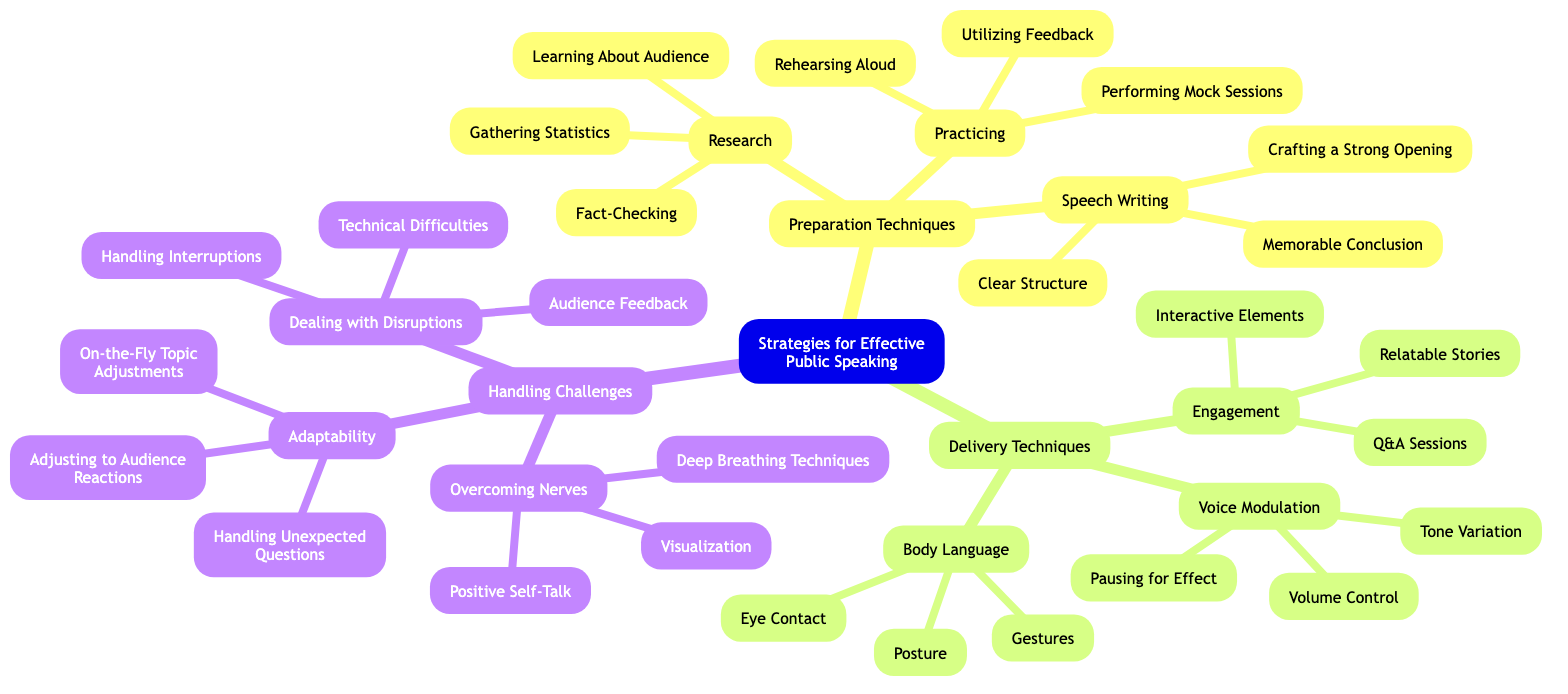What is the central topic of the mind map? The central topic is explicitly labeled as "Strategies for Effective Public Speaking". This is located at the root of the diagram.
Answer: Strategies for Effective Public Speaking How many subtopics are listed under the central topic? There are three main subtopics branching out from the central topic: Preparation Techniques, Delivery Techniques, and Handling Challenges. Counting these will provide the answer.
Answer: 3 What technique falls under the "Preparation Techniques" subtopic? One of the techniques listed under the "Preparation Techniques" is "Research", which includes several elements detailed below it.
Answer: Research Which delivery technique involves "Eye Contact"? "Eye Contact" appears under the subtopic "Body Language", which is part of the Delivery Techniques category. Thus, the relationship can be traced through the sections of the mind map.
Answer: Body Language What is one method for "Overcoming Nerves"? One of the listed methods for "Overcoming Nerves" is "Deep Breathing Techniques", which is stated under the corresponding subtopic in the diagram.
Answer: Deep Breathing Techniques How many elements are listed under "Speech Writing"? "Speech Writing" includes three elements: Crafting a Strong Opening, Clear Structure, and Memorable Conclusion. Counting these will provide the answer.
Answer: 3 Which subtopic contains "Interactive Elements"? "Interactive Elements" is found under the "Engagement" category which is part of the "Delivery Techniques". Tracing the path through the diagram shows this hierarchy.
Answer: Engagement What are two techniques to deal with disruptions? "Handling Interruptions" and "Technical Difficulties" are both techniques listed under the "Dealing with Disruptions" element of "Handling Challenges". Both techniques can be found listed together in the mind map.
Answer: Handling Interruptions, Technical Difficulties What is the relationship between "Practicing" and "Speech Writing"? Both "Practicing" and "Speech Writing" are elements under the "Preparation Techniques" subtopic, indicating they are part of the same category focused on foundational skills for effective public speaking.
Answer: Same subtopic 